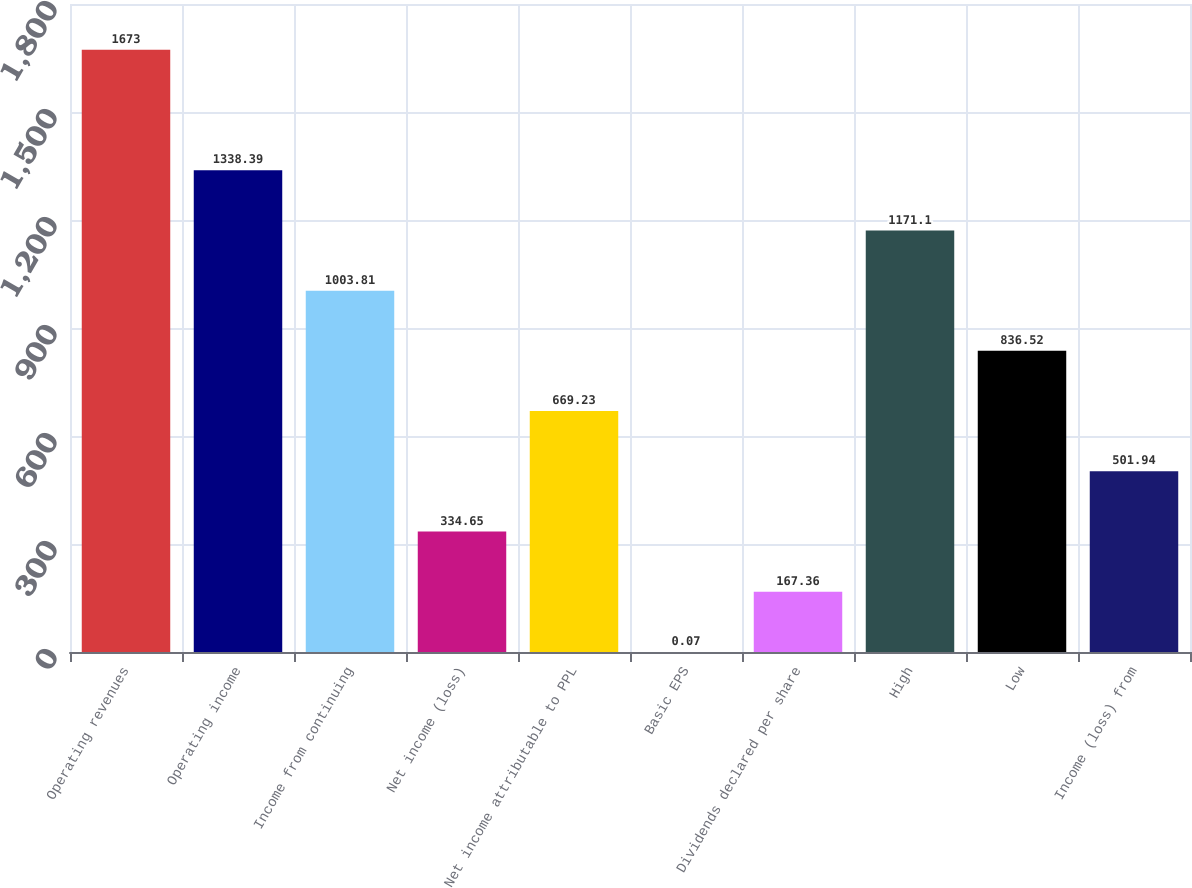Convert chart to OTSL. <chart><loc_0><loc_0><loc_500><loc_500><bar_chart><fcel>Operating revenues<fcel>Operating income<fcel>Income from continuing<fcel>Net income (loss)<fcel>Net income attributable to PPL<fcel>Basic EPS<fcel>Dividends declared per share<fcel>High<fcel>Low<fcel>Income (loss) from<nl><fcel>1673<fcel>1338.39<fcel>1003.81<fcel>334.65<fcel>669.23<fcel>0.07<fcel>167.36<fcel>1171.1<fcel>836.52<fcel>501.94<nl></chart> 